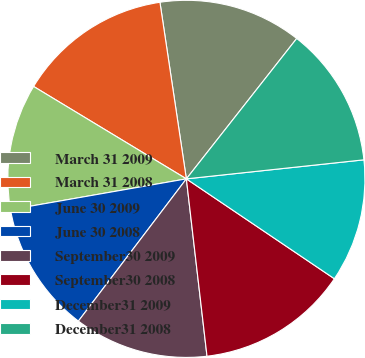Convert chart to OTSL. <chart><loc_0><loc_0><loc_500><loc_500><pie_chart><fcel>March 31 2009<fcel>March 31 2008<fcel>June 30 2009<fcel>June 30 2008<fcel>September30 2009<fcel>September30 2008<fcel>December31 2009<fcel>December31 2008<nl><fcel>12.97%<fcel>13.98%<fcel>11.42%<fcel>11.91%<fcel>12.18%<fcel>13.71%<fcel>11.15%<fcel>12.7%<nl></chart> 